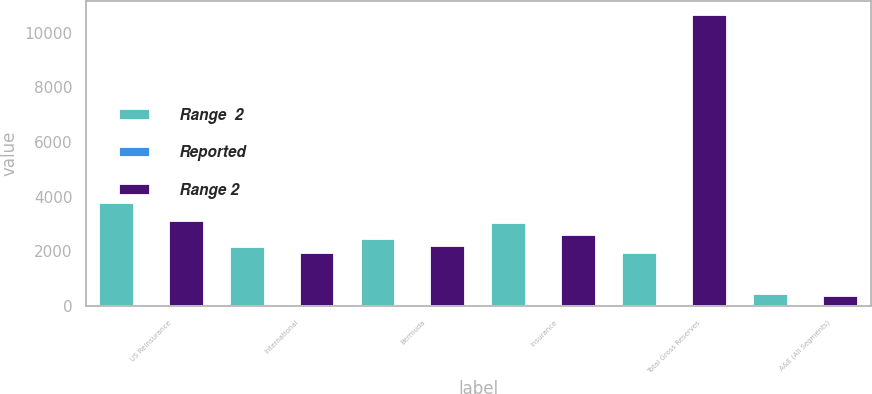Convert chart. <chart><loc_0><loc_0><loc_500><loc_500><stacked_bar_chart><ecel><fcel>US Reinsurance<fcel>International<fcel>Bermuda<fcel>Insurance<fcel>Total Gross Reserves<fcel>A&E (All Segments)<nl><fcel>Range  2<fcel>3760.6<fcel>2170.5<fcel>2454.8<fcel>3049.4<fcel>1946.8<fcel>449<nl><fcel>Reported<fcel>16.7<fcel>10.3<fcel>10.1<fcel>14.1<fcel>10.5<fcel>13.7<nl><fcel>Range 2<fcel>3131<fcel>1946.8<fcel>2206.4<fcel>2618.2<fcel>10639.1<fcel>387.5<nl></chart> 